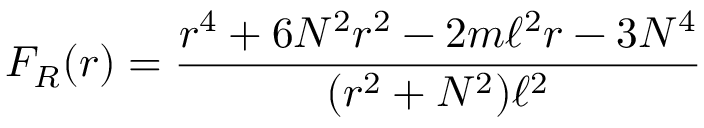<formula> <loc_0><loc_0><loc_500><loc_500>F _ { R } ( r ) = \frac { r ^ { 4 } + 6 N ^ { 2 } r ^ { 2 } - 2 m \ell ^ { 2 } r - 3 N ^ { 4 } } { ( r ^ { 2 } + N ^ { 2 } ) \ell ^ { 2 } }</formula> 